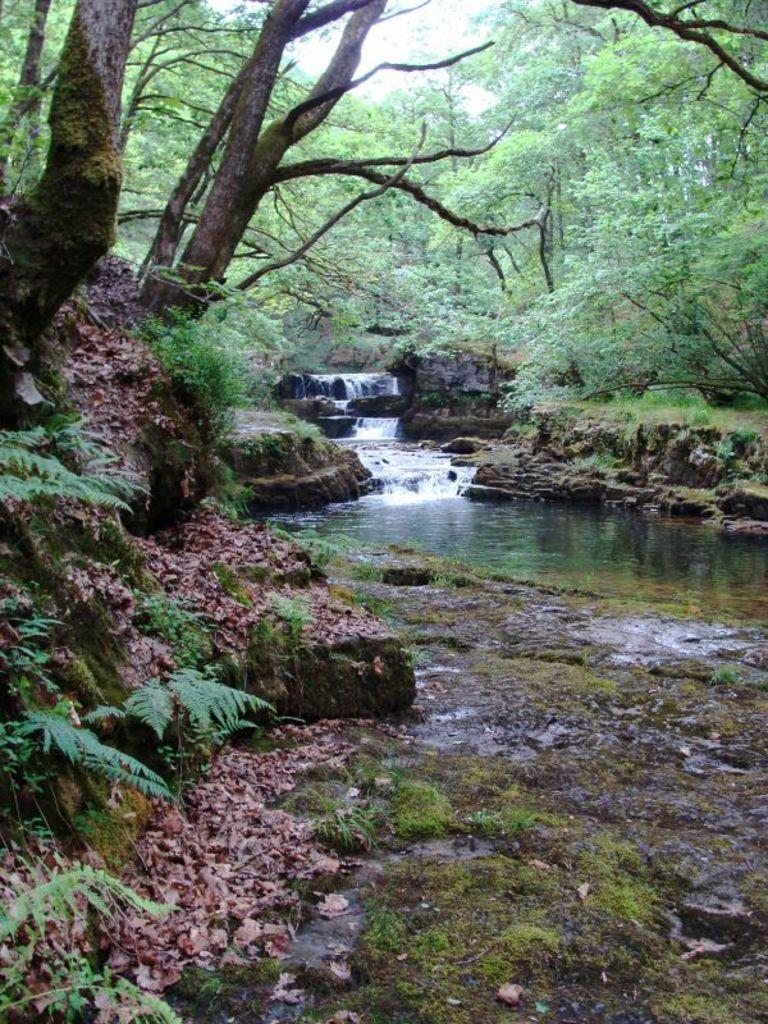What type of natural feature can be seen in the image? There is a small waterfall in the image. What is the condition of the ground in the image? There is water on the ground in the image. What type of vegetation is present in the image? Dry leaves are present on the ground in the image, and there are trees in the image. What type of popcorn is being served at the picnic in the image? There is no picnic or popcorn present in the image; it features a small waterfall, water on the ground, dry leaves, and trees. 